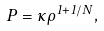<formula> <loc_0><loc_0><loc_500><loc_500>P = \kappa \rho ^ { 1 + 1 / N } ,</formula> 